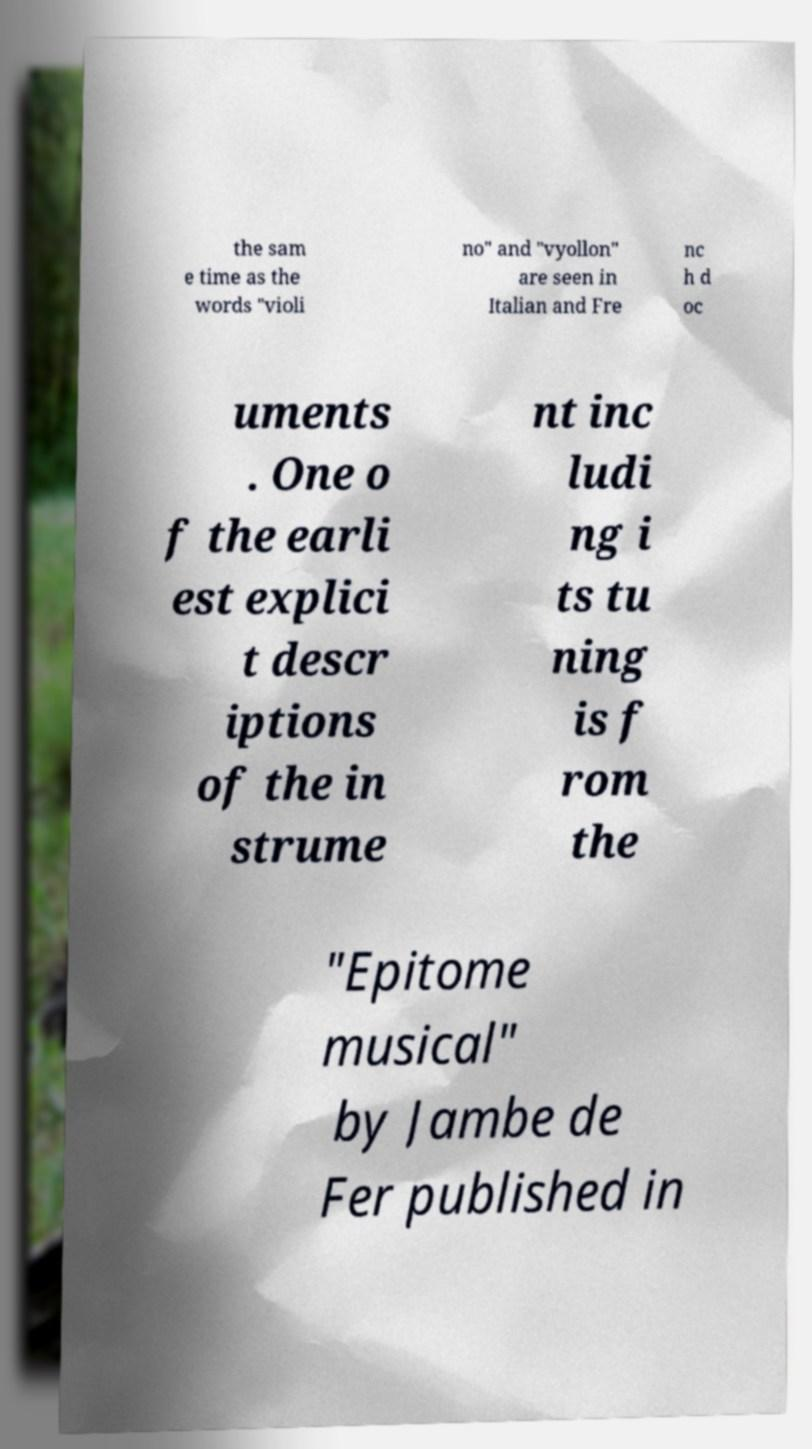Please identify and transcribe the text found in this image. the sam e time as the words "violi no" and "vyollon" are seen in Italian and Fre nc h d oc uments . One o f the earli est explici t descr iptions of the in strume nt inc ludi ng i ts tu ning is f rom the "Epitome musical" by Jambe de Fer published in 